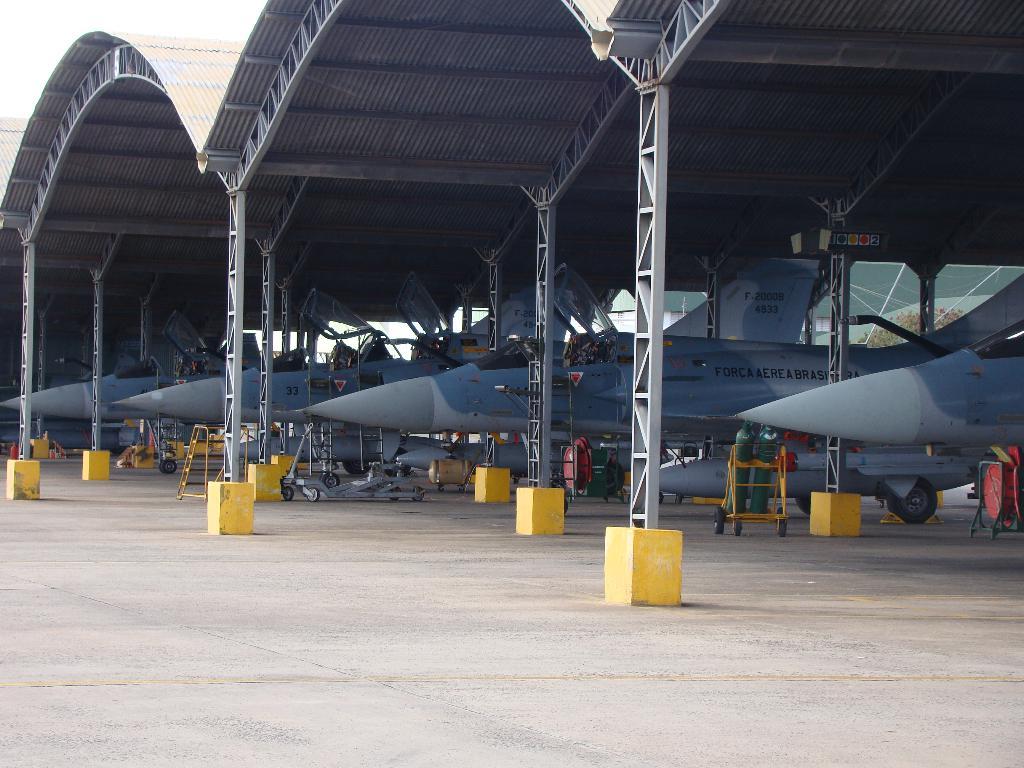What number is one of the jets?
Your answer should be very brief. 33. 